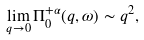<formula> <loc_0><loc_0><loc_500><loc_500>\lim _ { q \rightarrow 0 } \Pi _ { 0 } ^ { + \alpha } ( q , \omega ) \sim q ^ { 2 } ,</formula> 